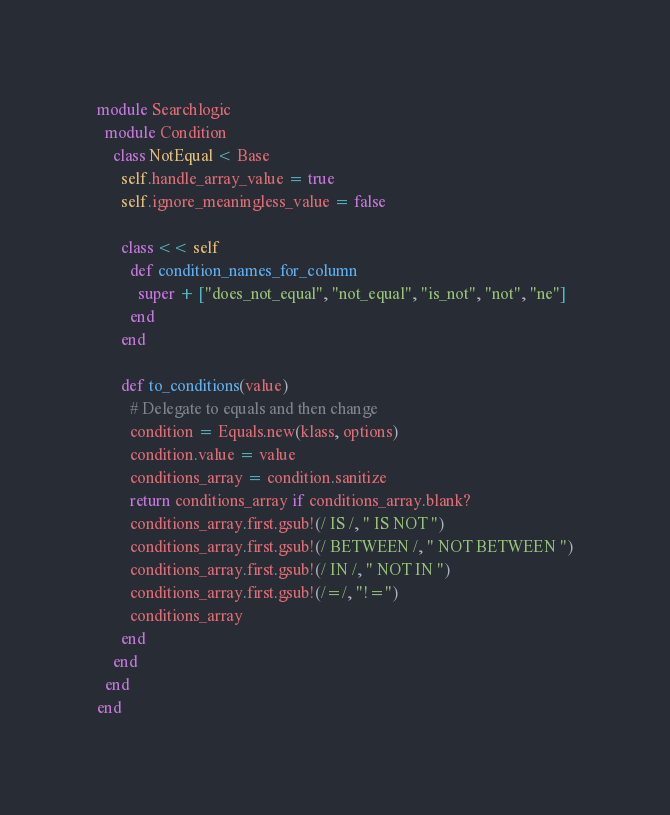Convert code to text. <code><loc_0><loc_0><loc_500><loc_500><_Ruby_>module Searchlogic
  module Condition
    class NotEqual < Base
      self.handle_array_value = true
      self.ignore_meaningless_value = false
      
      class << self
        def condition_names_for_column
          super + ["does_not_equal", "not_equal", "is_not", "not", "ne"]
        end
      end
      
      def to_conditions(value)
        # Delegate to equals and then change
        condition = Equals.new(klass, options)
        condition.value = value
        conditions_array = condition.sanitize
        return conditions_array if conditions_array.blank?
        conditions_array.first.gsub!(/ IS /, " IS NOT ")
        conditions_array.first.gsub!(/ BETWEEN /, " NOT BETWEEN ")
        conditions_array.first.gsub!(/ IN /, " NOT IN ")
        conditions_array.first.gsub!(/=/, "!=")
        conditions_array
      end
    end
  end
end</code> 